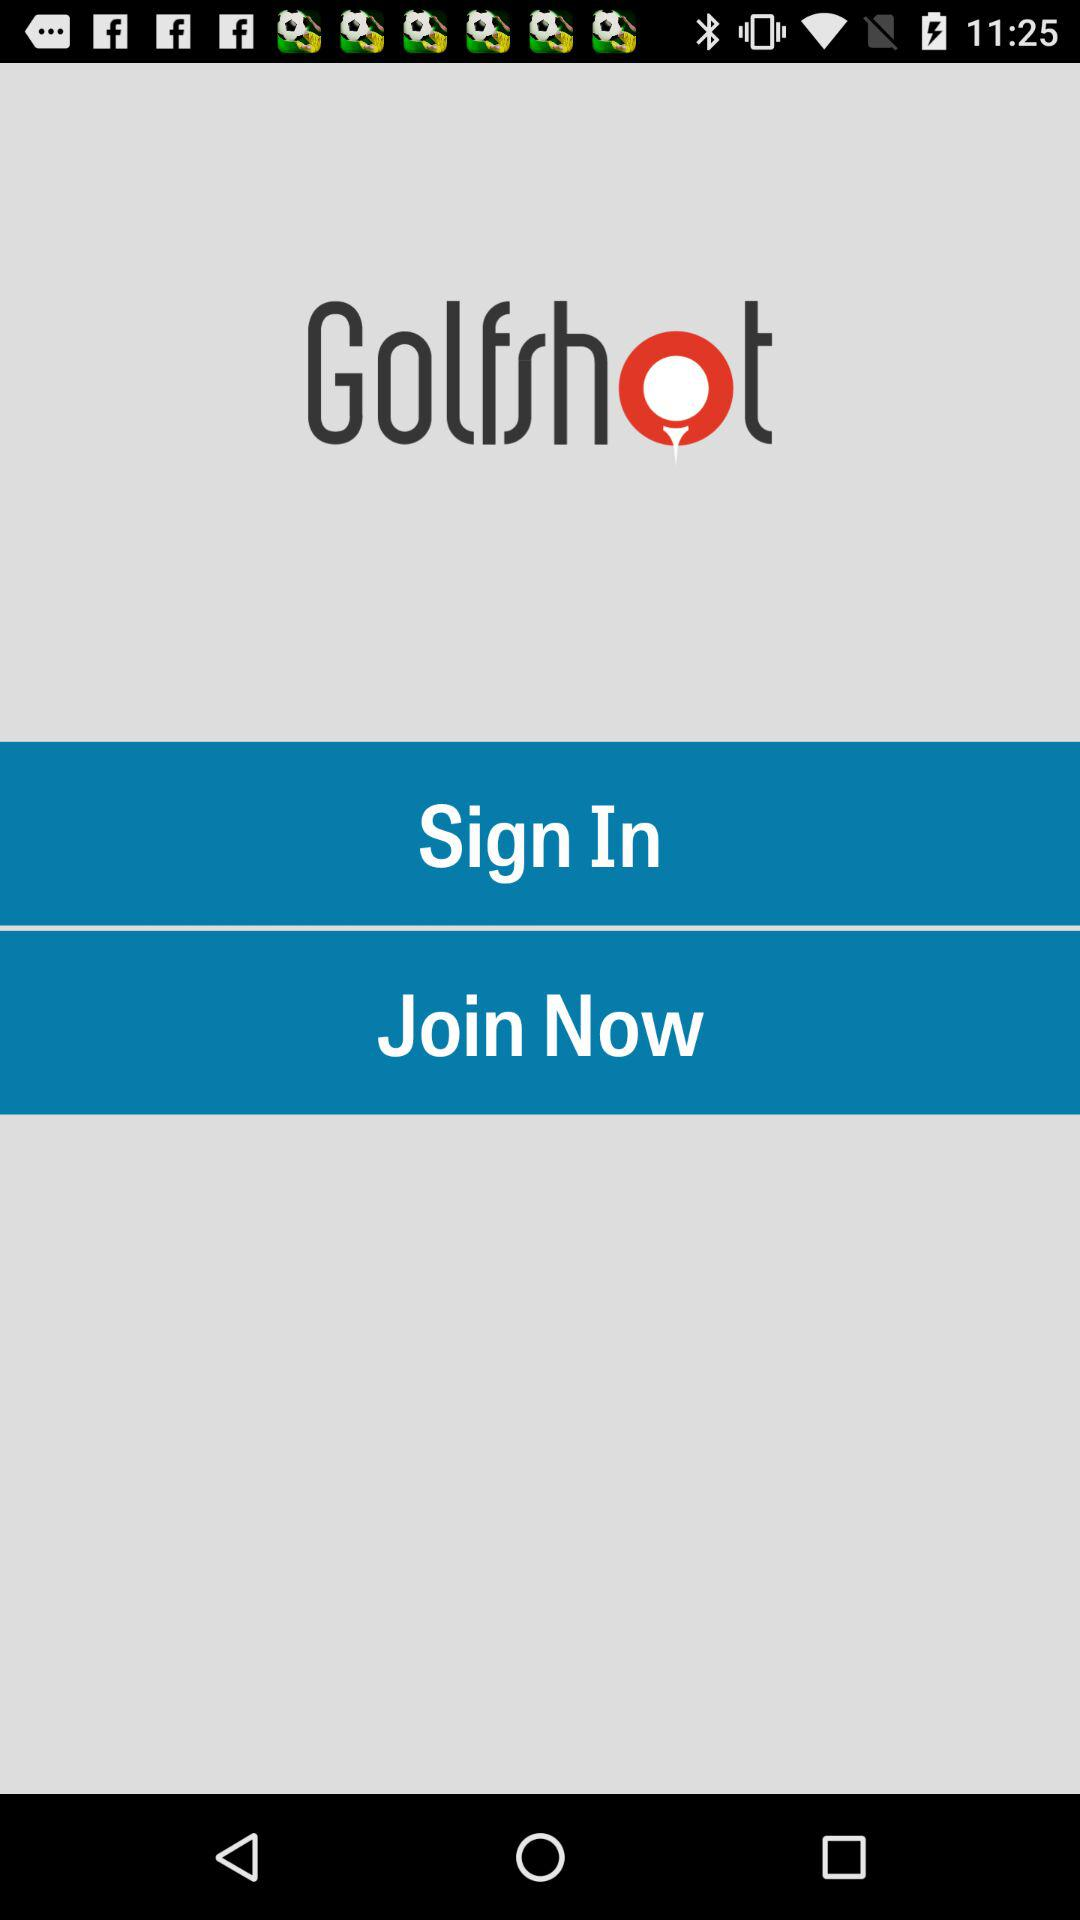What is the name of the application? The name of the application is "Golfshot". 